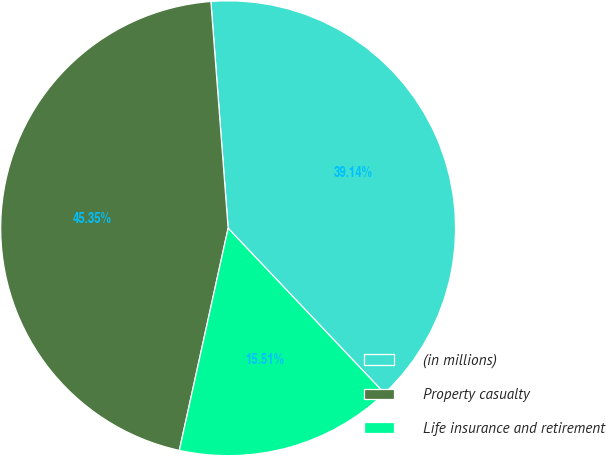<chart> <loc_0><loc_0><loc_500><loc_500><pie_chart><fcel>(in millions)<fcel>Property casualty<fcel>Life insurance and retirement<nl><fcel>39.14%<fcel>45.35%<fcel>15.51%<nl></chart> 